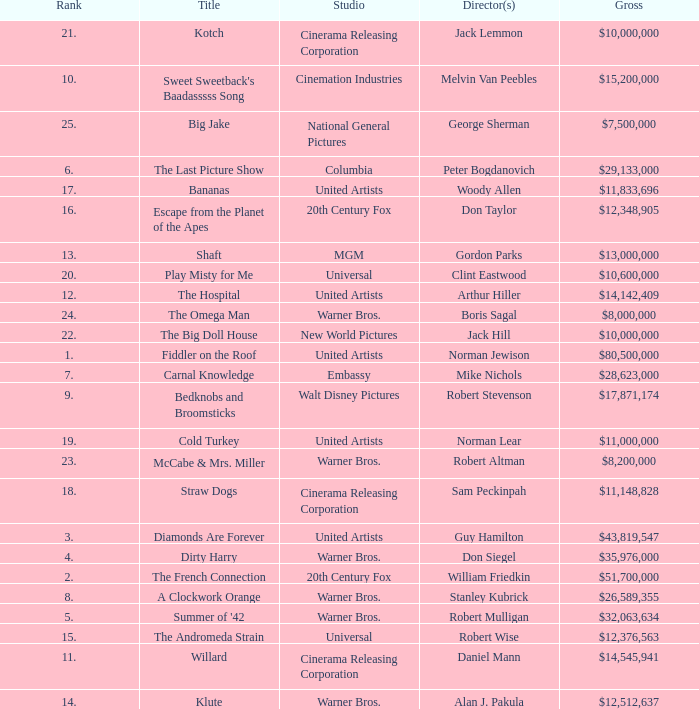What rank is the title with a gross of $26,589,355? 8.0. 